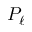<formula> <loc_0><loc_0><loc_500><loc_500>P _ { \ell }</formula> 